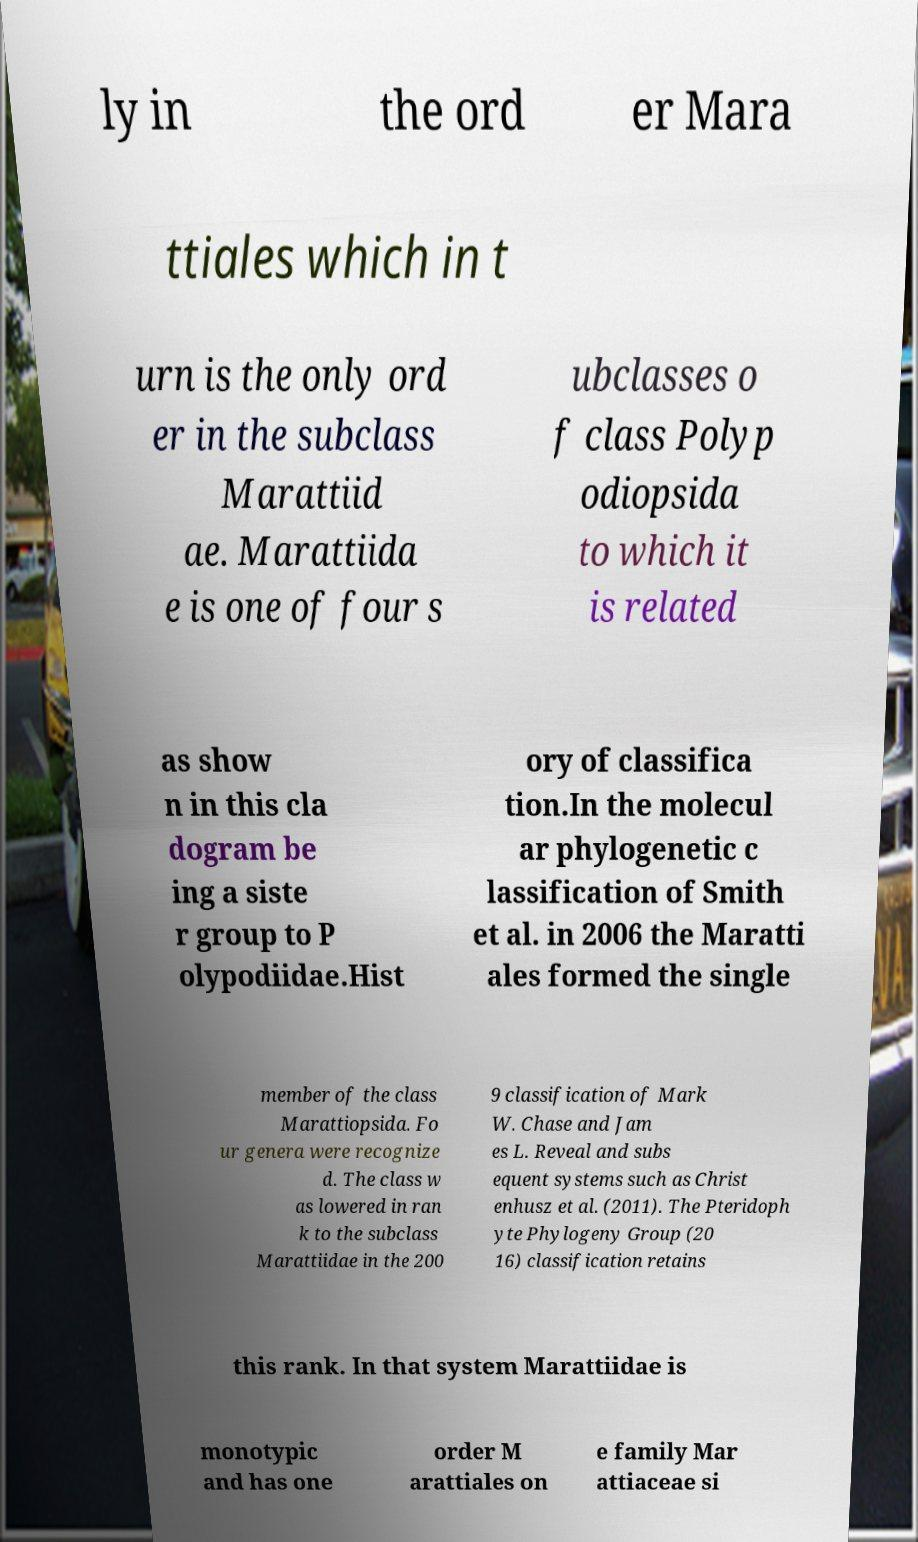Can you accurately transcribe the text from the provided image for me? ly in the ord er Mara ttiales which in t urn is the only ord er in the subclass Marattiid ae. Marattiida e is one of four s ubclasses o f class Polyp odiopsida to which it is related as show n in this cla dogram be ing a siste r group to P olypodiidae.Hist ory of classifica tion.In the molecul ar phylogenetic c lassification of Smith et al. in 2006 the Maratti ales formed the single member of the class Marattiopsida. Fo ur genera were recognize d. The class w as lowered in ran k to the subclass Marattiidae in the 200 9 classification of Mark W. Chase and Jam es L. Reveal and subs equent systems such as Christ enhusz et al. (2011). The Pteridoph yte Phylogeny Group (20 16) classification retains this rank. In that system Marattiidae is monotypic and has one order M arattiales on e family Mar attiaceae si 